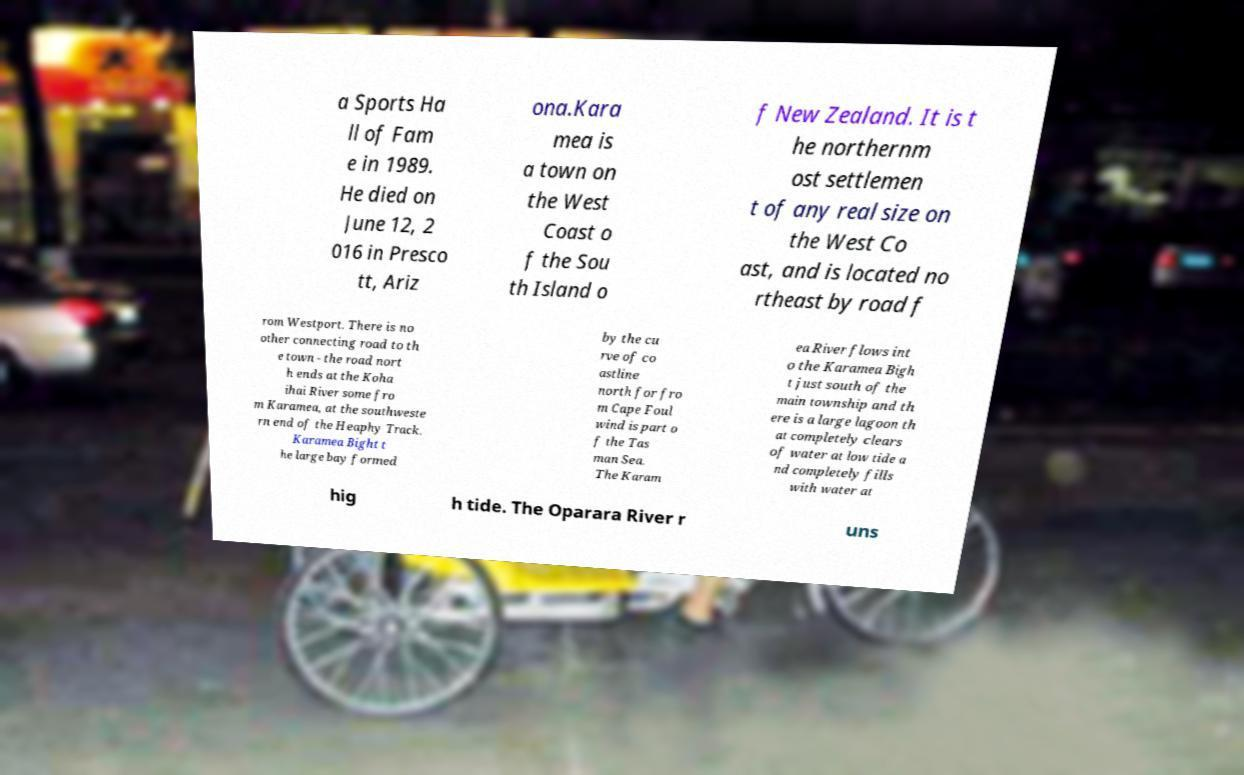I need the written content from this picture converted into text. Can you do that? a Sports Ha ll of Fam e in 1989. He died on June 12, 2 016 in Presco tt, Ariz ona.Kara mea is a town on the West Coast o f the Sou th Island o f New Zealand. It is t he northernm ost settlemen t of any real size on the West Co ast, and is located no rtheast by road f rom Westport. There is no other connecting road to th e town - the road nort h ends at the Koha ihai River some fro m Karamea, at the southweste rn end of the Heaphy Track. Karamea Bight t he large bay formed by the cu rve of co astline north for fro m Cape Foul wind is part o f the Tas man Sea. The Karam ea River flows int o the Karamea Bigh t just south of the main township and th ere is a large lagoon th at completely clears of water at low tide a nd completely fills with water at hig h tide. The Oparara River r uns 